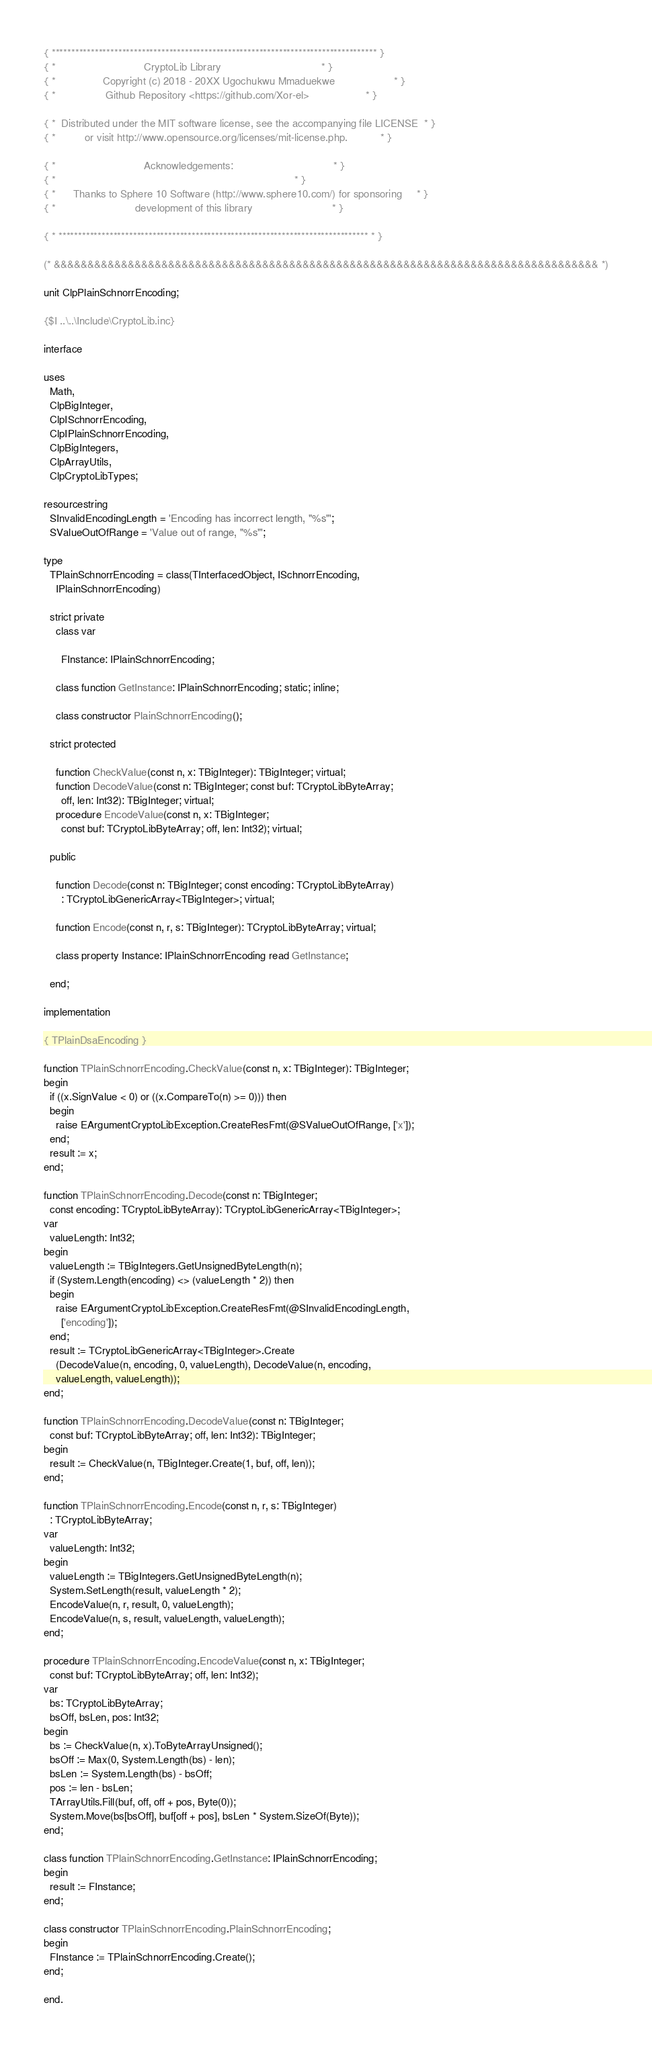Convert code to text. <code><loc_0><loc_0><loc_500><loc_500><_Pascal_>{ *********************************************************************************** }
{ *                              CryptoLib Library                                  * }
{ *                Copyright (c) 2018 - 20XX Ugochukwu Mmaduekwe                    * }
{ *                 Github Repository <https://github.com/Xor-el>                   * }

{ *  Distributed under the MIT software license, see the accompanying file LICENSE  * }
{ *          or visit http://www.opensource.org/licenses/mit-license.php.           * }

{ *                              Acknowledgements:                                  * }
{ *                                                                                 * }
{ *      Thanks to Sphere 10 Software (http://www.sphere10.com/) for sponsoring     * }
{ *                           development of this library                           * }

{ * ******************************************************************************* * }

(* &&&&&&&&&&&&&&&&&&&&&&&&&&&&&&&&&&&&&&&&&&&&&&&&&&&&&&&&&&&&&&&&&&&&&&&&&&&&&&&&& *)

unit ClpPlainSchnorrEncoding;

{$I ..\..\Include\CryptoLib.inc}

interface

uses
  Math,
  ClpBigInteger,
  ClpISchnorrEncoding,
  ClpIPlainSchnorrEncoding,
  ClpBigIntegers,
  ClpArrayUtils,
  ClpCryptoLibTypes;

resourcestring
  SInvalidEncodingLength = 'Encoding has incorrect length, "%s"';
  SValueOutOfRange = 'Value out of range, "%s"';

type
  TPlainSchnorrEncoding = class(TInterfacedObject, ISchnorrEncoding,
    IPlainSchnorrEncoding)

  strict private
    class var

      FInstance: IPlainSchnorrEncoding;

    class function GetInstance: IPlainSchnorrEncoding; static; inline;

    class constructor PlainSchnorrEncoding();

  strict protected

    function CheckValue(const n, x: TBigInteger): TBigInteger; virtual;
    function DecodeValue(const n: TBigInteger; const buf: TCryptoLibByteArray;
      off, len: Int32): TBigInteger; virtual;
    procedure EncodeValue(const n, x: TBigInteger;
      const buf: TCryptoLibByteArray; off, len: Int32); virtual;

  public

    function Decode(const n: TBigInteger; const encoding: TCryptoLibByteArray)
      : TCryptoLibGenericArray<TBigInteger>; virtual;

    function Encode(const n, r, s: TBigInteger): TCryptoLibByteArray; virtual;

    class property Instance: IPlainSchnorrEncoding read GetInstance;

  end;

implementation

{ TPlainDsaEncoding }

function TPlainSchnorrEncoding.CheckValue(const n, x: TBigInteger): TBigInteger;
begin
  if ((x.SignValue < 0) or ((x.CompareTo(n) >= 0))) then
  begin
    raise EArgumentCryptoLibException.CreateResFmt(@SValueOutOfRange, ['x']);
  end;
  result := x;
end;

function TPlainSchnorrEncoding.Decode(const n: TBigInteger;
  const encoding: TCryptoLibByteArray): TCryptoLibGenericArray<TBigInteger>;
var
  valueLength: Int32;
begin
  valueLength := TBigIntegers.GetUnsignedByteLength(n);
  if (System.Length(encoding) <> (valueLength * 2)) then
  begin
    raise EArgumentCryptoLibException.CreateResFmt(@SInvalidEncodingLength,
      ['encoding']);
  end;
  result := TCryptoLibGenericArray<TBigInteger>.Create
    (DecodeValue(n, encoding, 0, valueLength), DecodeValue(n, encoding,
    valueLength, valueLength));
end;

function TPlainSchnorrEncoding.DecodeValue(const n: TBigInteger;
  const buf: TCryptoLibByteArray; off, len: Int32): TBigInteger;
begin
  result := CheckValue(n, TBigInteger.Create(1, buf, off, len));
end;

function TPlainSchnorrEncoding.Encode(const n, r, s: TBigInteger)
  : TCryptoLibByteArray;
var
  valueLength: Int32;
begin
  valueLength := TBigIntegers.GetUnsignedByteLength(n);
  System.SetLength(result, valueLength * 2);
  EncodeValue(n, r, result, 0, valueLength);
  EncodeValue(n, s, result, valueLength, valueLength);
end;

procedure TPlainSchnorrEncoding.EncodeValue(const n, x: TBigInteger;
  const buf: TCryptoLibByteArray; off, len: Int32);
var
  bs: TCryptoLibByteArray;
  bsOff, bsLen, pos: Int32;
begin
  bs := CheckValue(n, x).ToByteArrayUnsigned();
  bsOff := Max(0, System.Length(bs) - len);
  bsLen := System.Length(bs) - bsOff;
  pos := len - bsLen;
  TArrayUtils.Fill(buf, off, off + pos, Byte(0));
  System.Move(bs[bsOff], buf[off + pos], bsLen * System.SizeOf(Byte));
end;

class function TPlainSchnorrEncoding.GetInstance: IPlainSchnorrEncoding;
begin
  result := FInstance;
end;

class constructor TPlainSchnorrEncoding.PlainSchnorrEncoding;
begin
  FInstance := TPlainSchnorrEncoding.Create();
end;

end.
</code> 